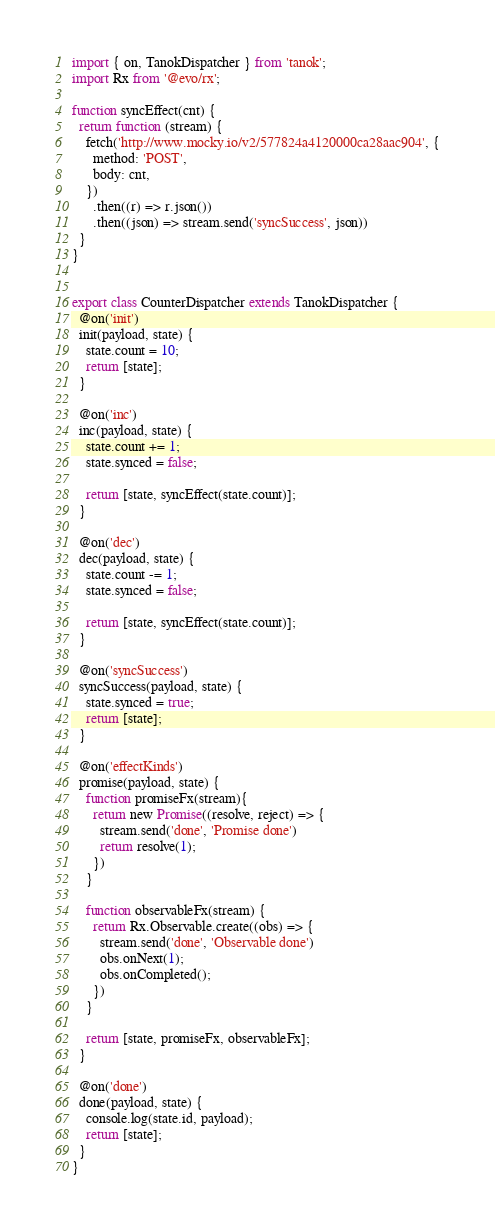<code> <loc_0><loc_0><loc_500><loc_500><_JavaScript_>import { on, TanokDispatcher } from 'tanok';
import Rx from '@evo/rx';

function syncEffect(cnt) {
  return function (stream) {
    fetch('http://www.mocky.io/v2/577824a4120000ca28aac904', {
      method: 'POST',
      body: cnt,
    })
      .then((r) => r.json())
      .then((json) => stream.send('syncSuccess', json))
  }
}


export class CounterDispatcher extends TanokDispatcher {
  @on('init')
  init(payload, state) {
    state.count = 10;
    return [state];
  }

  @on('inc')
  inc(payload, state) {
    state.count += 1;
    state.synced = false;

    return [state, syncEffect(state.count)];
  }

  @on('dec')
  dec(payload, state) {
    state.count -= 1;
    state.synced = false;

    return [state, syncEffect(state.count)];
  }

  @on('syncSuccess')
  syncSuccess(payload, state) {
    state.synced = true;
    return [state];
  }

  @on('effectKinds')
  promise(payload, state) {
    function promiseFx(stream){
      return new Promise((resolve, reject) => {
        stream.send('done', 'Promise done')
        return resolve(1);
      })
    }

    function observableFx(stream) {
      return Rx.Observable.create((obs) => {
        stream.send('done', 'Observable done')
        obs.onNext(1);
        obs.onCompleted();
      })
    }

    return [state, promiseFx, observableFx];
  }

  @on('done')
  done(payload, state) {
    console.log(state.id, payload);
    return [state];
  }
}
</code> 